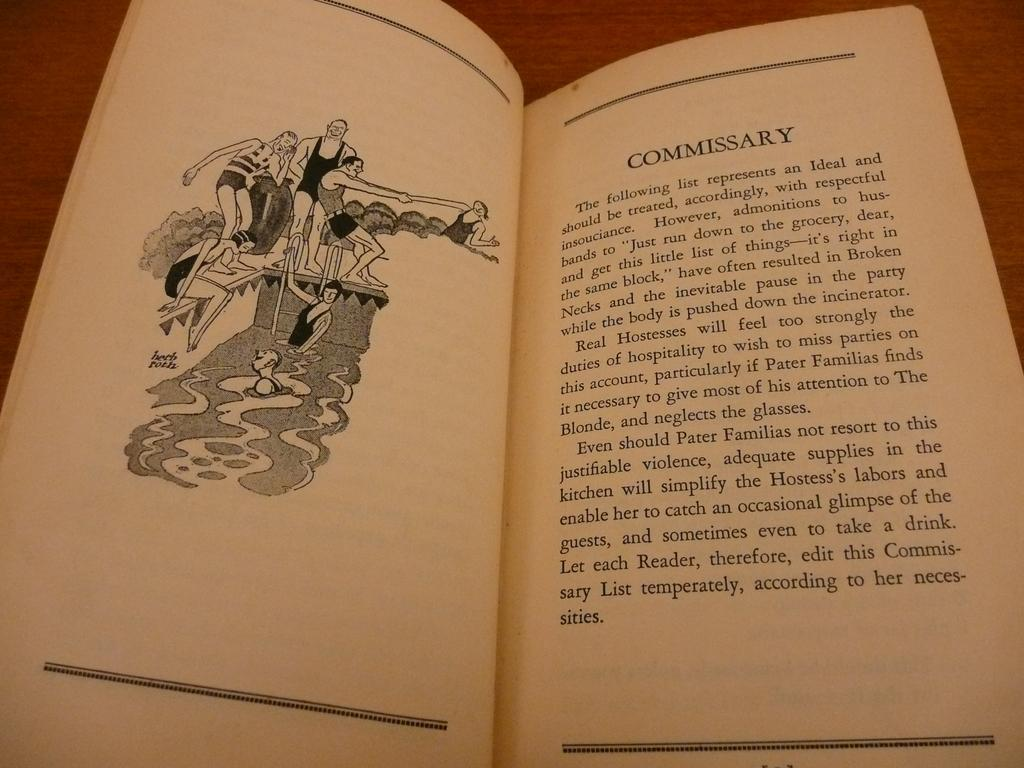<image>
Write a terse but informative summary of the picture. A passage in a book labeled "Commissary" is next to a black and white drawing of people at a swimming pool. 